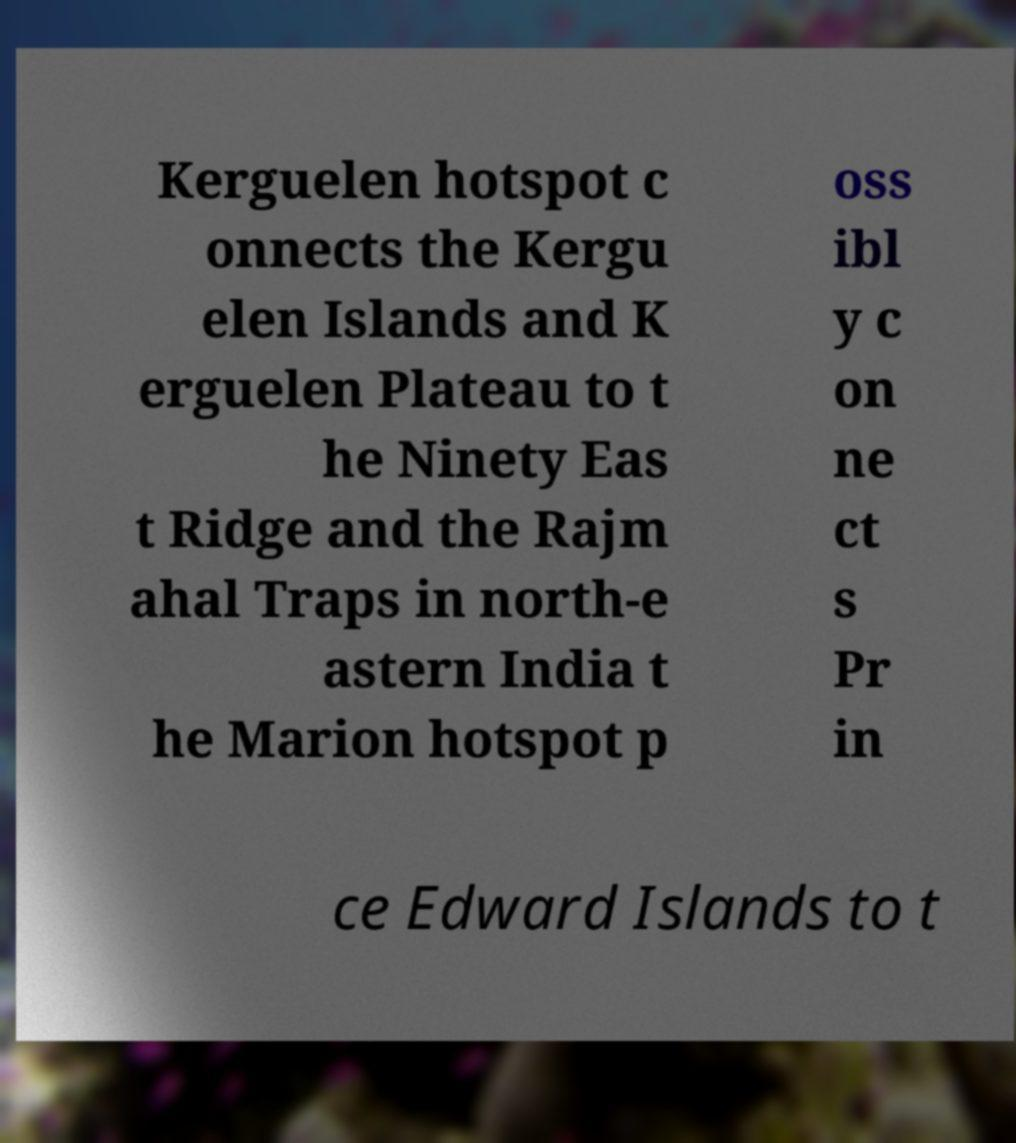Please read and relay the text visible in this image. What does it say? Kerguelen hotspot c onnects the Kergu elen Islands and K erguelen Plateau to t he Ninety Eas t Ridge and the Rajm ahal Traps in north-e astern India t he Marion hotspot p oss ibl y c on ne ct s Pr in ce Edward Islands to t 